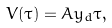<formula> <loc_0><loc_0><loc_500><loc_500>V ( \tau ) = A y _ { d } \tau ,</formula> 